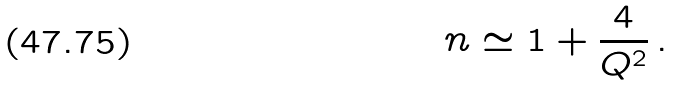<formula> <loc_0><loc_0><loc_500><loc_500>n \simeq 1 + \frac { 4 } { Q ^ { 2 } } \, .</formula> 